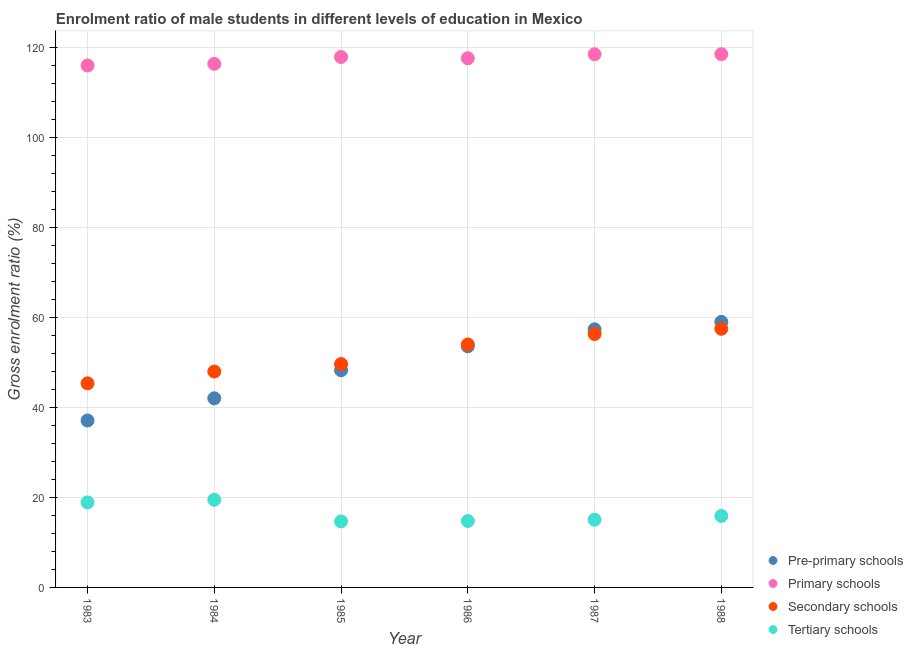What is the gross enrolment ratio(female) in tertiary schools in 1985?
Your response must be concise. 14.66. Across all years, what is the maximum gross enrolment ratio(female) in secondary schools?
Ensure brevity in your answer.  57.43. Across all years, what is the minimum gross enrolment ratio(female) in tertiary schools?
Your answer should be very brief. 14.66. In which year was the gross enrolment ratio(female) in secondary schools maximum?
Provide a short and direct response. 1988. What is the total gross enrolment ratio(female) in tertiary schools in the graph?
Offer a very short reply. 98.69. What is the difference between the gross enrolment ratio(female) in pre-primary schools in 1985 and that in 1988?
Give a very brief answer. -10.76. What is the difference between the gross enrolment ratio(female) in primary schools in 1985 and the gross enrolment ratio(female) in tertiary schools in 1986?
Offer a terse response. 103.05. What is the average gross enrolment ratio(female) in primary schools per year?
Offer a very short reply. 117.4. In the year 1987, what is the difference between the gross enrolment ratio(female) in primary schools and gross enrolment ratio(female) in pre-primary schools?
Offer a very short reply. 61.1. What is the ratio of the gross enrolment ratio(female) in secondary schools in 1987 to that in 1988?
Ensure brevity in your answer.  0.98. Is the difference between the gross enrolment ratio(female) in secondary schools in 1984 and 1988 greater than the difference between the gross enrolment ratio(female) in primary schools in 1984 and 1988?
Offer a very short reply. No. What is the difference between the highest and the second highest gross enrolment ratio(female) in secondary schools?
Give a very brief answer. 1.15. What is the difference between the highest and the lowest gross enrolment ratio(female) in tertiary schools?
Your response must be concise. 4.8. In how many years, is the gross enrolment ratio(female) in pre-primary schools greater than the average gross enrolment ratio(female) in pre-primary schools taken over all years?
Provide a succinct answer. 3. Is it the case that in every year, the sum of the gross enrolment ratio(female) in primary schools and gross enrolment ratio(female) in tertiary schools is greater than the sum of gross enrolment ratio(female) in secondary schools and gross enrolment ratio(female) in pre-primary schools?
Provide a succinct answer. No. Is it the case that in every year, the sum of the gross enrolment ratio(female) in pre-primary schools and gross enrolment ratio(female) in primary schools is greater than the gross enrolment ratio(female) in secondary schools?
Ensure brevity in your answer.  Yes. Does the gross enrolment ratio(female) in secondary schools monotonically increase over the years?
Make the answer very short. Yes. Is the gross enrolment ratio(female) in secondary schools strictly greater than the gross enrolment ratio(female) in tertiary schools over the years?
Your answer should be very brief. Yes. Is the gross enrolment ratio(female) in primary schools strictly less than the gross enrolment ratio(female) in pre-primary schools over the years?
Ensure brevity in your answer.  No. How many years are there in the graph?
Ensure brevity in your answer.  6. What is the difference between two consecutive major ticks on the Y-axis?
Your answer should be very brief. 20. Does the graph contain any zero values?
Your response must be concise. No. How are the legend labels stacked?
Your answer should be compact. Vertical. What is the title of the graph?
Your answer should be compact. Enrolment ratio of male students in different levels of education in Mexico. What is the label or title of the X-axis?
Ensure brevity in your answer.  Year. What is the label or title of the Y-axis?
Keep it short and to the point. Gross enrolment ratio (%). What is the Gross enrolment ratio (%) in Pre-primary schools in 1983?
Make the answer very short. 37.08. What is the Gross enrolment ratio (%) of Primary schools in 1983?
Your response must be concise. 115.92. What is the Gross enrolment ratio (%) of Secondary schools in 1983?
Your response must be concise. 45.33. What is the Gross enrolment ratio (%) of Tertiary schools in 1983?
Your answer should be very brief. 18.89. What is the Gross enrolment ratio (%) of Pre-primary schools in 1984?
Your response must be concise. 42.01. What is the Gross enrolment ratio (%) of Primary schools in 1984?
Provide a short and direct response. 116.28. What is the Gross enrolment ratio (%) of Secondary schools in 1984?
Make the answer very short. 47.94. What is the Gross enrolment ratio (%) of Tertiary schools in 1984?
Your response must be concise. 19.46. What is the Gross enrolment ratio (%) in Pre-primary schools in 1985?
Give a very brief answer. 48.21. What is the Gross enrolment ratio (%) of Primary schools in 1985?
Your answer should be compact. 117.81. What is the Gross enrolment ratio (%) of Secondary schools in 1985?
Your answer should be very brief. 49.62. What is the Gross enrolment ratio (%) in Tertiary schools in 1985?
Make the answer very short. 14.66. What is the Gross enrolment ratio (%) in Pre-primary schools in 1986?
Offer a terse response. 53.54. What is the Gross enrolment ratio (%) in Primary schools in 1986?
Your response must be concise. 117.53. What is the Gross enrolment ratio (%) in Secondary schools in 1986?
Provide a short and direct response. 53.95. What is the Gross enrolment ratio (%) in Tertiary schools in 1986?
Offer a very short reply. 14.75. What is the Gross enrolment ratio (%) in Pre-primary schools in 1987?
Make the answer very short. 57.32. What is the Gross enrolment ratio (%) in Primary schools in 1987?
Keep it short and to the point. 118.42. What is the Gross enrolment ratio (%) in Secondary schools in 1987?
Your answer should be compact. 56.28. What is the Gross enrolment ratio (%) in Tertiary schools in 1987?
Give a very brief answer. 15.04. What is the Gross enrolment ratio (%) in Pre-primary schools in 1988?
Your response must be concise. 58.97. What is the Gross enrolment ratio (%) of Primary schools in 1988?
Your answer should be compact. 118.43. What is the Gross enrolment ratio (%) of Secondary schools in 1988?
Make the answer very short. 57.43. What is the Gross enrolment ratio (%) in Tertiary schools in 1988?
Offer a very short reply. 15.88. Across all years, what is the maximum Gross enrolment ratio (%) in Pre-primary schools?
Your answer should be very brief. 58.97. Across all years, what is the maximum Gross enrolment ratio (%) in Primary schools?
Provide a succinct answer. 118.43. Across all years, what is the maximum Gross enrolment ratio (%) of Secondary schools?
Give a very brief answer. 57.43. Across all years, what is the maximum Gross enrolment ratio (%) of Tertiary schools?
Give a very brief answer. 19.46. Across all years, what is the minimum Gross enrolment ratio (%) in Pre-primary schools?
Provide a short and direct response. 37.08. Across all years, what is the minimum Gross enrolment ratio (%) of Primary schools?
Your answer should be very brief. 115.92. Across all years, what is the minimum Gross enrolment ratio (%) in Secondary schools?
Your response must be concise. 45.33. Across all years, what is the minimum Gross enrolment ratio (%) of Tertiary schools?
Provide a short and direct response. 14.66. What is the total Gross enrolment ratio (%) of Pre-primary schools in the graph?
Offer a terse response. 297.13. What is the total Gross enrolment ratio (%) of Primary schools in the graph?
Ensure brevity in your answer.  704.38. What is the total Gross enrolment ratio (%) of Secondary schools in the graph?
Your answer should be compact. 310.55. What is the total Gross enrolment ratio (%) of Tertiary schools in the graph?
Offer a very short reply. 98.69. What is the difference between the Gross enrolment ratio (%) in Pre-primary schools in 1983 and that in 1984?
Your response must be concise. -4.93. What is the difference between the Gross enrolment ratio (%) of Primary schools in 1983 and that in 1984?
Keep it short and to the point. -0.36. What is the difference between the Gross enrolment ratio (%) of Secondary schools in 1983 and that in 1984?
Offer a terse response. -2.61. What is the difference between the Gross enrolment ratio (%) of Tertiary schools in 1983 and that in 1984?
Your answer should be compact. -0.58. What is the difference between the Gross enrolment ratio (%) of Pre-primary schools in 1983 and that in 1985?
Your answer should be very brief. -11.14. What is the difference between the Gross enrolment ratio (%) of Primary schools in 1983 and that in 1985?
Make the answer very short. -1.89. What is the difference between the Gross enrolment ratio (%) in Secondary schools in 1983 and that in 1985?
Keep it short and to the point. -4.29. What is the difference between the Gross enrolment ratio (%) of Tertiary schools in 1983 and that in 1985?
Offer a terse response. 4.23. What is the difference between the Gross enrolment ratio (%) of Pre-primary schools in 1983 and that in 1986?
Offer a very short reply. -16.46. What is the difference between the Gross enrolment ratio (%) in Primary schools in 1983 and that in 1986?
Offer a very short reply. -1.61. What is the difference between the Gross enrolment ratio (%) of Secondary schools in 1983 and that in 1986?
Provide a short and direct response. -8.62. What is the difference between the Gross enrolment ratio (%) of Tertiary schools in 1983 and that in 1986?
Make the answer very short. 4.13. What is the difference between the Gross enrolment ratio (%) in Pre-primary schools in 1983 and that in 1987?
Make the answer very short. -20.24. What is the difference between the Gross enrolment ratio (%) in Primary schools in 1983 and that in 1987?
Provide a succinct answer. -2.5. What is the difference between the Gross enrolment ratio (%) in Secondary schools in 1983 and that in 1987?
Ensure brevity in your answer.  -10.95. What is the difference between the Gross enrolment ratio (%) in Tertiary schools in 1983 and that in 1987?
Offer a very short reply. 3.85. What is the difference between the Gross enrolment ratio (%) in Pre-primary schools in 1983 and that in 1988?
Give a very brief answer. -21.9. What is the difference between the Gross enrolment ratio (%) of Primary schools in 1983 and that in 1988?
Your response must be concise. -2.51. What is the difference between the Gross enrolment ratio (%) in Secondary schools in 1983 and that in 1988?
Provide a succinct answer. -12.11. What is the difference between the Gross enrolment ratio (%) of Tertiary schools in 1983 and that in 1988?
Your answer should be compact. 3.01. What is the difference between the Gross enrolment ratio (%) of Pre-primary schools in 1984 and that in 1985?
Your answer should be very brief. -6.21. What is the difference between the Gross enrolment ratio (%) of Primary schools in 1984 and that in 1985?
Keep it short and to the point. -1.53. What is the difference between the Gross enrolment ratio (%) in Secondary schools in 1984 and that in 1985?
Offer a terse response. -1.68. What is the difference between the Gross enrolment ratio (%) of Tertiary schools in 1984 and that in 1985?
Give a very brief answer. 4.8. What is the difference between the Gross enrolment ratio (%) of Pre-primary schools in 1984 and that in 1986?
Provide a succinct answer. -11.54. What is the difference between the Gross enrolment ratio (%) in Primary schools in 1984 and that in 1986?
Your answer should be compact. -1.25. What is the difference between the Gross enrolment ratio (%) in Secondary schools in 1984 and that in 1986?
Offer a terse response. -6.01. What is the difference between the Gross enrolment ratio (%) of Tertiary schools in 1984 and that in 1986?
Provide a short and direct response. 4.71. What is the difference between the Gross enrolment ratio (%) in Pre-primary schools in 1984 and that in 1987?
Provide a short and direct response. -15.32. What is the difference between the Gross enrolment ratio (%) of Primary schools in 1984 and that in 1987?
Your answer should be very brief. -2.14. What is the difference between the Gross enrolment ratio (%) in Secondary schools in 1984 and that in 1987?
Your response must be concise. -8.34. What is the difference between the Gross enrolment ratio (%) in Tertiary schools in 1984 and that in 1987?
Your answer should be very brief. 4.42. What is the difference between the Gross enrolment ratio (%) of Pre-primary schools in 1984 and that in 1988?
Ensure brevity in your answer.  -16.97. What is the difference between the Gross enrolment ratio (%) in Primary schools in 1984 and that in 1988?
Provide a short and direct response. -2.15. What is the difference between the Gross enrolment ratio (%) of Secondary schools in 1984 and that in 1988?
Offer a terse response. -9.49. What is the difference between the Gross enrolment ratio (%) of Tertiary schools in 1984 and that in 1988?
Keep it short and to the point. 3.59. What is the difference between the Gross enrolment ratio (%) in Pre-primary schools in 1985 and that in 1986?
Offer a very short reply. -5.33. What is the difference between the Gross enrolment ratio (%) in Primary schools in 1985 and that in 1986?
Provide a short and direct response. 0.28. What is the difference between the Gross enrolment ratio (%) of Secondary schools in 1985 and that in 1986?
Give a very brief answer. -4.33. What is the difference between the Gross enrolment ratio (%) of Tertiary schools in 1985 and that in 1986?
Provide a short and direct response. -0.09. What is the difference between the Gross enrolment ratio (%) in Pre-primary schools in 1985 and that in 1987?
Make the answer very short. -9.11. What is the difference between the Gross enrolment ratio (%) in Primary schools in 1985 and that in 1987?
Provide a short and direct response. -0.61. What is the difference between the Gross enrolment ratio (%) in Secondary schools in 1985 and that in 1987?
Offer a terse response. -6.66. What is the difference between the Gross enrolment ratio (%) in Tertiary schools in 1985 and that in 1987?
Your response must be concise. -0.38. What is the difference between the Gross enrolment ratio (%) in Pre-primary schools in 1985 and that in 1988?
Offer a very short reply. -10.76. What is the difference between the Gross enrolment ratio (%) of Primary schools in 1985 and that in 1988?
Ensure brevity in your answer.  -0.62. What is the difference between the Gross enrolment ratio (%) in Secondary schools in 1985 and that in 1988?
Your response must be concise. -7.82. What is the difference between the Gross enrolment ratio (%) of Tertiary schools in 1985 and that in 1988?
Keep it short and to the point. -1.21. What is the difference between the Gross enrolment ratio (%) in Pre-primary schools in 1986 and that in 1987?
Ensure brevity in your answer.  -3.78. What is the difference between the Gross enrolment ratio (%) of Primary schools in 1986 and that in 1987?
Ensure brevity in your answer.  -0.9. What is the difference between the Gross enrolment ratio (%) of Secondary schools in 1986 and that in 1987?
Keep it short and to the point. -2.33. What is the difference between the Gross enrolment ratio (%) of Tertiary schools in 1986 and that in 1987?
Your answer should be compact. -0.29. What is the difference between the Gross enrolment ratio (%) of Pre-primary schools in 1986 and that in 1988?
Make the answer very short. -5.43. What is the difference between the Gross enrolment ratio (%) of Primary schools in 1986 and that in 1988?
Make the answer very short. -0.9. What is the difference between the Gross enrolment ratio (%) in Secondary schools in 1986 and that in 1988?
Give a very brief answer. -3.49. What is the difference between the Gross enrolment ratio (%) in Tertiary schools in 1986 and that in 1988?
Provide a short and direct response. -1.12. What is the difference between the Gross enrolment ratio (%) of Pre-primary schools in 1987 and that in 1988?
Your answer should be compact. -1.65. What is the difference between the Gross enrolment ratio (%) of Primary schools in 1987 and that in 1988?
Provide a short and direct response. -0.01. What is the difference between the Gross enrolment ratio (%) of Secondary schools in 1987 and that in 1988?
Provide a short and direct response. -1.15. What is the difference between the Gross enrolment ratio (%) in Tertiary schools in 1987 and that in 1988?
Your answer should be compact. -0.83. What is the difference between the Gross enrolment ratio (%) in Pre-primary schools in 1983 and the Gross enrolment ratio (%) in Primary schools in 1984?
Provide a succinct answer. -79.2. What is the difference between the Gross enrolment ratio (%) of Pre-primary schools in 1983 and the Gross enrolment ratio (%) of Secondary schools in 1984?
Provide a succinct answer. -10.86. What is the difference between the Gross enrolment ratio (%) of Pre-primary schools in 1983 and the Gross enrolment ratio (%) of Tertiary schools in 1984?
Provide a succinct answer. 17.61. What is the difference between the Gross enrolment ratio (%) in Primary schools in 1983 and the Gross enrolment ratio (%) in Secondary schools in 1984?
Give a very brief answer. 67.98. What is the difference between the Gross enrolment ratio (%) of Primary schools in 1983 and the Gross enrolment ratio (%) of Tertiary schools in 1984?
Provide a succinct answer. 96.45. What is the difference between the Gross enrolment ratio (%) of Secondary schools in 1983 and the Gross enrolment ratio (%) of Tertiary schools in 1984?
Make the answer very short. 25.86. What is the difference between the Gross enrolment ratio (%) of Pre-primary schools in 1983 and the Gross enrolment ratio (%) of Primary schools in 1985?
Offer a very short reply. -80.73. What is the difference between the Gross enrolment ratio (%) in Pre-primary schools in 1983 and the Gross enrolment ratio (%) in Secondary schools in 1985?
Your response must be concise. -12.54. What is the difference between the Gross enrolment ratio (%) in Pre-primary schools in 1983 and the Gross enrolment ratio (%) in Tertiary schools in 1985?
Your answer should be compact. 22.42. What is the difference between the Gross enrolment ratio (%) of Primary schools in 1983 and the Gross enrolment ratio (%) of Secondary schools in 1985?
Your response must be concise. 66.3. What is the difference between the Gross enrolment ratio (%) in Primary schools in 1983 and the Gross enrolment ratio (%) in Tertiary schools in 1985?
Give a very brief answer. 101.25. What is the difference between the Gross enrolment ratio (%) in Secondary schools in 1983 and the Gross enrolment ratio (%) in Tertiary schools in 1985?
Your response must be concise. 30.66. What is the difference between the Gross enrolment ratio (%) in Pre-primary schools in 1983 and the Gross enrolment ratio (%) in Primary schools in 1986?
Offer a terse response. -80.45. What is the difference between the Gross enrolment ratio (%) in Pre-primary schools in 1983 and the Gross enrolment ratio (%) in Secondary schools in 1986?
Offer a very short reply. -16.87. What is the difference between the Gross enrolment ratio (%) in Pre-primary schools in 1983 and the Gross enrolment ratio (%) in Tertiary schools in 1986?
Make the answer very short. 22.32. What is the difference between the Gross enrolment ratio (%) in Primary schools in 1983 and the Gross enrolment ratio (%) in Secondary schools in 1986?
Provide a short and direct response. 61.97. What is the difference between the Gross enrolment ratio (%) of Primary schools in 1983 and the Gross enrolment ratio (%) of Tertiary schools in 1986?
Keep it short and to the point. 101.16. What is the difference between the Gross enrolment ratio (%) in Secondary schools in 1983 and the Gross enrolment ratio (%) in Tertiary schools in 1986?
Make the answer very short. 30.57. What is the difference between the Gross enrolment ratio (%) in Pre-primary schools in 1983 and the Gross enrolment ratio (%) in Primary schools in 1987?
Offer a terse response. -81.34. What is the difference between the Gross enrolment ratio (%) of Pre-primary schools in 1983 and the Gross enrolment ratio (%) of Secondary schools in 1987?
Your answer should be compact. -19.2. What is the difference between the Gross enrolment ratio (%) of Pre-primary schools in 1983 and the Gross enrolment ratio (%) of Tertiary schools in 1987?
Offer a very short reply. 22.04. What is the difference between the Gross enrolment ratio (%) of Primary schools in 1983 and the Gross enrolment ratio (%) of Secondary schools in 1987?
Offer a terse response. 59.64. What is the difference between the Gross enrolment ratio (%) in Primary schools in 1983 and the Gross enrolment ratio (%) in Tertiary schools in 1987?
Ensure brevity in your answer.  100.87. What is the difference between the Gross enrolment ratio (%) of Secondary schools in 1983 and the Gross enrolment ratio (%) of Tertiary schools in 1987?
Make the answer very short. 30.28. What is the difference between the Gross enrolment ratio (%) in Pre-primary schools in 1983 and the Gross enrolment ratio (%) in Primary schools in 1988?
Provide a succinct answer. -81.35. What is the difference between the Gross enrolment ratio (%) of Pre-primary schools in 1983 and the Gross enrolment ratio (%) of Secondary schools in 1988?
Keep it short and to the point. -20.36. What is the difference between the Gross enrolment ratio (%) in Pre-primary schools in 1983 and the Gross enrolment ratio (%) in Tertiary schools in 1988?
Provide a succinct answer. 21.2. What is the difference between the Gross enrolment ratio (%) of Primary schools in 1983 and the Gross enrolment ratio (%) of Secondary schools in 1988?
Provide a short and direct response. 58.48. What is the difference between the Gross enrolment ratio (%) of Primary schools in 1983 and the Gross enrolment ratio (%) of Tertiary schools in 1988?
Offer a terse response. 100.04. What is the difference between the Gross enrolment ratio (%) of Secondary schools in 1983 and the Gross enrolment ratio (%) of Tertiary schools in 1988?
Ensure brevity in your answer.  29.45. What is the difference between the Gross enrolment ratio (%) in Pre-primary schools in 1984 and the Gross enrolment ratio (%) in Primary schools in 1985?
Your answer should be compact. -75.8. What is the difference between the Gross enrolment ratio (%) in Pre-primary schools in 1984 and the Gross enrolment ratio (%) in Secondary schools in 1985?
Offer a very short reply. -7.61. What is the difference between the Gross enrolment ratio (%) of Pre-primary schools in 1984 and the Gross enrolment ratio (%) of Tertiary schools in 1985?
Keep it short and to the point. 27.34. What is the difference between the Gross enrolment ratio (%) in Primary schools in 1984 and the Gross enrolment ratio (%) in Secondary schools in 1985?
Provide a succinct answer. 66.66. What is the difference between the Gross enrolment ratio (%) in Primary schools in 1984 and the Gross enrolment ratio (%) in Tertiary schools in 1985?
Your answer should be compact. 101.61. What is the difference between the Gross enrolment ratio (%) of Secondary schools in 1984 and the Gross enrolment ratio (%) of Tertiary schools in 1985?
Your answer should be very brief. 33.28. What is the difference between the Gross enrolment ratio (%) of Pre-primary schools in 1984 and the Gross enrolment ratio (%) of Primary schools in 1986?
Provide a short and direct response. -75.52. What is the difference between the Gross enrolment ratio (%) of Pre-primary schools in 1984 and the Gross enrolment ratio (%) of Secondary schools in 1986?
Give a very brief answer. -11.94. What is the difference between the Gross enrolment ratio (%) of Pre-primary schools in 1984 and the Gross enrolment ratio (%) of Tertiary schools in 1986?
Your answer should be compact. 27.25. What is the difference between the Gross enrolment ratio (%) of Primary schools in 1984 and the Gross enrolment ratio (%) of Secondary schools in 1986?
Provide a succinct answer. 62.33. What is the difference between the Gross enrolment ratio (%) in Primary schools in 1984 and the Gross enrolment ratio (%) in Tertiary schools in 1986?
Your answer should be very brief. 101.52. What is the difference between the Gross enrolment ratio (%) in Secondary schools in 1984 and the Gross enrolment ratio (%) in Tertiary schools in 1986?
Ensure brevity in your answer.  33.19. What is the difference between the Gross enrolment ratio (%) in Pre-primary schools in 1984 and the Gross enrolment ratio (%) in Primary schools in 1987?
Provide a succinct answer. -76.42. What is the difference between the Gross enrolment ratio (%) of Pre-primary schools in 1984 and the Gross enrolment ratio (%) of Secondary schools in 1987?
Make the answer very short. -14.27. What is the difference between the Gross enrolment ratio (%) of Pre-primary schools in 1984 and the Gross enrolment ratio (%) of Tertiary schools in 1987?
Your response must be concise. 26.96. What is the difference between the Gross enrolment ratio (%) in Primary schools in 1984 and the Gross enrolment ratio (%) in Secondary schools in 1987?
Offer a terse response. 60. What is the difference between the Gross enrolment ratio (%) in Primary schools in 1984 and the Gross enrolment ratio (%) in Tertiary schools in 1987?
Your answer should be compact. 101.23. What is the difference between the Gross enrolment ratio (%) in Secondary schools in 1984 and the Gross enrolment ratio (%) in Tertiary schools in 1987?
Ensure brevity in your answer.  32.9. What is the difference between the Gross enrolment ratio (%) in Pre-primary schools in 1984 and the Gross enrolment ratio (%) in Primary schools in 1988?
Keep it short and to the point. -76.42. What is the difference between the Gross enrolment ratio (%) of Pre-primary schools in 1984 and the Gross enrolment ratio (%) of Secondary schools in 1988?
Offer a terse response. -15.43. What is the difference between the Gross enrolment ratio (%) of Pre-primary schools in 1984 and the Gross enrolment ratio (%) of Tertiary schools in 1988?
Provide a succinct answer. 26.13. What is the difference between the Gross enrolment ratio (%) of Primary schools in 1984 and the Gross enrolment ratio (%) of Secondary schools in 1988?
Your answer should be compact. 58.84. What is the difference between the Gross enrolment ratio (%) in Primary schools in 1984 and the Gross enrolment ratio (%) in Tertiary schools in 1988?
Give a very brief answer. 100.4. What is the difference between the Gross enrolment ratio (%) in Secondary schools in 1984 and the Gross enrolment ratio (%) in Tertiary schools in 1988?
Give a very brief answer. 32.07. What is the difference between the Gross enrolment ratio (%) in Pre-primary schools in 1985 and the Gross enrolment ratio (%) in Primary schools in 1986?
Make the answer very short. -69.31. What is the difference between the Gross enrolment ratio (%) in Pre-primary schools in 1985 and the Gross enrolment ratio (%) in Secondary schools in 1986?
Provide a succinct answer. -5.74. What is the difference between the Gross enrolment ratio (%) of Pre-primary schools in 1985 and the Gross enrolment ratio (%) of Tertiary schools in 1986?
Give a very brief answer. 33.46. What is the difference between the Gross enrolment ratio (%) of Primary schools in 1985 and the Gross enrolment ratio (%) of Secondary schools in 1986?
Give a very brief answer. 63.86. What is the difference between the Gross enrolment ratio (%) of Primary schools in 1985 and the Gross enrolment ratio (%) of Tertiary schools in 1986?
Offer a very short reply. 103.05. What is the difference between the Gross enrolment ratio (%) of Secondary schools in 1985 and the Gross enrolment ratio (%) of Tertiary schools in 1986?
Provide a short and direct response. 34.86. What is the difference between the Gross enrolment ratio (%) of Pre-primary schools in 1985 and the Gross enrolment ratio (%) of Primary schools in 1987?
Your response must be concise. -70.21. What is the difference between the Gross enrolment ratio (%) in Pre-primary schools in 1985 and the Gross enrolment ratio (%) in Secondary schools in 1987?
Your answer should be very brief. -8.07. What is the difference between the Gross enrolment ratio (%) of Pre-primary schools in 1985 and the Gross enrolment ratio (%) of Tertiary schools in 1987?
Give a very brief answer. 33.17. What is the difference between the Gross enrolment ratio (%) in Primary schools in 1985 and the Gross enrolment ratio (%) in Secondary schools in 1987?
Provide a short and direct response. 61.53. What is the difference between the Gross enrolment ratio (%) in Primary schools in 1985 and the Gross enrolment ratio (%) in Tertiary schools in 1987?
Offer a terse response. 102.77. What is the difference between the Gross enrolment ratio (%) in Secondary schools in 1985 and the Gross enrolment ratio (%) in Tertiary schools in 1987?
Offer a terse response. 34.57. What is the difference between the Gross enrolment ratio (%) of Pre-primary schools in 1985 and the Gross enrolment ratio (%) of Primary schools in 1988?
Give a very brief answer. -70.21. What is the difference between the Gross enrolment ratio (%) of Pre-primary schools in 1985 and the Gross enrolment ratio (%) of Secondary schools in 1988?
Your answer should be very brief. -9.22. What is the difference between the Gross enrolment ratio (%) in Pre-primary schools in 1985 and the Gross enrolment ratio (%) in Tertiary schools in 1988?
Offer a terse response. 32.34. What is the difference between the Gross enrolment ratio (%) of Primary schools in 1985 and the Gross enrolment ratio (%) of Secondary schools in 1988?
Give a very brief answer. 60.37. What is the difference between the Gross enrolment ratio (%) of Primary schools in 1985 and the Gross enrolment ratio (%) of Tertiary schools in 1988?
Your answer should be compact. 101.93. What is the difference between the Gross enrolment ratio (%) in Secondary schools in 1985 and the Gross enrolment ratio (%) in Tertiary schools in 1988?
Your response must be concise. 33.74. What is the difference between the Gross enrolment ratio (%) in Pre-primary schools in 1986 and the Gross enrolment ratio (%) in Primary schools in 1987?
Offer a terse response. -64.88. What is the difference between the Gross enrolment ratio (%) of Pre-primary schools in 1986 and the Gross enrolment ratio (%) of Secondary schools in 1987?
Ensure brevity in your answer.  -2.74. What is the difference between the Gross enrolment ratio (%) in Pre-primary schools in 1986 and the Gross enrolment ratio (%) in Tertiary schools in 1987?
Provide a succinct answer. 38.5. What is the difference between the Gross enrolment ratio (%) of Primary schools in 1986 and the Gross enrolment ratio (%) of Secondary schools in 1987?
Make the answer very short. 61.25. What is the difference between the Gross enrolment ratio (%) in Primary schools in 1986 and the Gross enrolment ratio (%) in Tertiary schools in 1987?
Make the answer very short. 102.48. What is the difference between the Gross enrolment ratio (%) in Secondary schools in 1986 and the Gross enrolment ratio (%) in Tertiary schools in 1987?
Keep it short and to the point. 38.91. What is the difference between the Gross enrolment ratio (%) in Pre-primary schools in 1986 and the Gross enrolment ratio (%) in Primary schools in 1988?
Give a very brief answer. -64.89. What is the difference between the Gross enrolment ratio (%) of Pre-primary schools in 1986 and the Gross enrolment ratio (%) of Secondary schools in 1988?
Offer a very short reply. -3.89. What is the difference between the Gross enrolment ratio (%) in Pre-primary schools in 1986 and the Gross enrolment ratio (%) in Tertiary schools in 1988?
Keep it short and to the point. 37.67. What is the difference between the Gross enrolment ratio (%) in Primary schools in 1986 and the Gross enrolment ratio (%) in Secondary schools in 1988?
Keep it short and to the point. 60.09. What is the difference between the Gross enrolment ratio (%) of Primary schools in 1986 and the Gross enrolment ratio (%) of Tertiary schools in 1988?
Keep it short and to the point. 101.65. What is the difference between the Gross enrolment ratio (%) of Secondary schools in 1986 and the Gross enrolment ratio (%) of Tertiary schools in 1988?
Offer a very short reply. 38.07. What is the difference between the Gross enrolment ratio (%) of Pre-primary schools in 1987 and the Gross enrolment ratio (%) of Primary schools in 1988?
Your answer should be very brief. -61.11. What is the difference between the Gross enrolment ratio (%) in Pre-primary schools in 1987 and the Gross enrolment ratio (%) in Secondary schools in 1988?
Make the answer very short. -0.11. What is the difference between the Gross enrolment ratio (%) of Pre-primary schools in 1987 and the Gross enrolment ratio (%) of Tertiary schools in 1988?
Offer a very short reply. 41.45. What is the difference between the Gross enrolment ratio (%) of Primary schools in 1987 and the Gross enrolment ratio (%) of Secondary schools in 1988?
Ensure brevity in your answer.  60.99. What is the difference between the Gross enrolment ratio (%) in Primary schools in 1987 and the Gross enrolment ratio (%) in Tertiary schools in 1988?
Make the answer very short. 102.55. What is the difference between the Gross enrolment ratio (%) in Secondary schools in 1987 and the Gross enrolment ratio (%) in Tertiary schools in 1988?
Provide a short and direct response. 40.41. What is the average Gross enrolment ratio (%) in Pre-primary schools per year?
Your answer should be very brief. 49.52. What is the average Gross enrolment ratio (%) of Primary schools per year?
Give a very brief answer. 117.4. What is the average Gross enrolment ratio (%) in Secondary schools per year?
Your answer should be very brief. 51.76. What is the average Gross enrolment ratio (%) of Tertiary schools per year?
Your response must be concise. 16.45. In the year 1983, what is the difference between the Gross enrolment ratio (%) of Pre-primary schools and Gross enrolment ratio (%) of Primary schools?
Offer a terse response. -78.84. In the year 1983, what is the difference between the Gross enrolment ratio (%) of Pre-primary schools and Gross enrolment ratio (%) of Secondary schools?
Your response must be concise. -8.25. In the year 1983, what is the difference between the Gross enrolment ratio (%) of Pre-primary schools and Gross enrolment ratio (%) of Tertiary schools?
Provide a succinct answer. 18.19. In the year 1983, what is the difference between the Gross enrolment ratio (%) in Primary schools and Gross enrolment ratio (%) in Secondary schools?
Your answer should be very brief. 70.59. In the year 1983, what is the difference between the Gross enrolment ratio (%) of Primary schools and Gross enrolment ratio (%) of Tertiary schools?
Offer a very short reply. 97.03. In the year 1983, what is the difference between the Gross enrolment ratio (%) in Secondary schools and Gross enrolment ratio (%) in Tertiary schools?
Offer a very short reply. 26.44. In the year 1984, what is the difference between the Gross enrolment ratio (%) in Pre-primary schools and Gross enrolment ratio (%) in Primary schools?
Ensure brevity in your answer.  -74.27. In the year 1984, what is the difference between the Gross enrolment ratio (%) of Pre-primary schools and Gross enrolment ratio (%) of Secondary schools?
Provide a short and direct response. -5.94. In the year 1984, what is the difference between the Gross enrolment ratio (%) of Pre-primary schools and Gross enrolment ratio (%) of Tertiary schools?
Offer a terse response. 22.54. In the year 1984, what is the difference between the Gross enrolment ratio (%) in Primary schools and Gross enrolment ratio (%) in Secondary schools?
Your response must be concise. 68.34. In the year 1984, what is the difference between the Gross enrolment ratio (%) of Primary schools and Gross enrolment ratio (%) of Tertiary schools?
Offer a very short reply. 96.81. In the year 1984, what is the difference between the Gross enrolment ratio (%) of Secondary schools and Gross enrolment ratio (%) of Tertiary schools?
Your answer should be compact. 28.48. In the year 1985, what is the difference between the Gross enrolment ratio (%) of Pre-primary schools and Gross enrolment ratio (%) of Primary schools?
Provide a short and direct response. -69.59. In the year 1985, what is the difference between the Gross enrolment ratio (%) of Pre-primary schools and Gross enrolment ratio (%) of Secondary schools?
Your response must be concise. -1.4. In the year 1985, what is the difference between the Gross enrolment ratio (%) in Pre-primary schools and Gross enrolment ratio (%) in Tertiary schools?
Your answer should be compact. 33.55. In the year 1985, what is the difference between the Gross enrolment ratio (%) of Primary schools and Gross enrolment ratio (%) of Secondary schools?
Provide a succinct answer. 68.19. In the year 1985, what is the difference between the Gross enrolment ratio (%) in Primary schools and Gross enrolment ratio (%) in Tertiary schools?
Your answer should be compact. 103.15. In the year 1985, what is the difference between the Gross enrolment ratio (%) of Secondary schools and Gross enrolment ratio (%) of Tertiary schools?
Make the answer very short. 34.95. In the year 1986, what is the difference between the Gross enrolment ratio (%) in Pre-primary schools and Gross enrolment ratio (%) in Primary schools?
Keep it short and to the point. -63.99. In the year 1986, what is the difference between the Gross enrolment ratio (%) in Pre-primary schools and Gross enrolment ratio (%) in Secondary schools?
Give a very brief answer. -0.41. In the year 1986, what is the difference between the Gross enrolment ratio (%) of Pre-primary schools and Gross enrolment ratio (%) of Tertiary schools?
Offer a very short reply. 38.79. In the year 1986, what is the difference between the Gross enrolment ratio (%) in Primary schools and Gross enrolment ratio (%) in Secondary schools?
Your response must be concise. 63.58. In the year 1986, what is the difference between the Gross enrolment ratio (%) of Primary schools and Gross enrolment ratio (%) of Tertiary schools?
Offer a very short reply. 102.77. In the year 1986, what is the difference between the Gross enrolment ratio (%) in Secondary schools and Gross enrolment ratio (%) in Tertiary schools?
Your response must be concise. 39.2. In the year 1987, what is the difference between the Gross enrolment ratio (%) of Pre-primary schools and Gross enrolment ratio (%) of Primary schools?
Offer a terse response. -61.1. In the year 1987, what is the difference between the Gross enrolment ratio (%) in Pre-primary schools and Gross enrolment ratio (%) in Secondary schools?
Ensure brevity in your answer.  1.04. In the year 1987, what is the difference between the Gross enrolment ratio (%) of Pre-primary schools and Gross enrolment ratio (%) of Tertiary schools?
Provide a short and direct response. 42.28. In the year 1987, what is the difference between the Gross enrolment ratio (%) in Primary schools and Gross enrolment ratio (%) in Secondary schools?
Your answer should be very brief. 62.14. In the year 1987, what is the difference between the Gross enrolment ratio (%) of Primary schools and Gross enrolment ratio (%) of Tertiary schools?
Your answer should be compact. 103.38. In the year 1987, what is the difference between the Gross enrolment ratio (%) of Secondary schools and Gross enrolment ratio (%) of Tertiary schools?
Your answer should be compact. 41.24. In the year 1988, what is the difference between the Gross enrolment ratio (%) in Pre-primary schools and Gross enrolment ratio (%) in Primary schools?
Provide a short and direct response. -59.45. In the year 1988, what is the difference between the Gross enrolment ratio (%) of Pre-primary schools and Gross enrolment ratio (%) of Secondary schools?
Give a very brief answer. 1.54. In the year 1988, what is the difference between the Gross enrolment ratio (%) in Pre-primary schools and Gross enrolment ratio (%) in Tertiary schools?
Offer a terse response. 43.1. In the year 1988, what is the difference between the Gross enrolment ratio (%) in Primary schools and Gross enrolment ratio (%) in Secondary schools?
Keep it short and to the point. 60.99. In the year 1988, what is the difference between the Gross enrolment ratio (%) of Primary schools and Gross enrolment ratio (%) of Tertiary schools?
Make the answer very short. 102.55. In the year 1988, what is the difference between the Gross enrolment ratio (%) in Secondary schools and Gross enrolment ratio (%) in Tertiary schools?
Your response must be concise. 41.56. What is the ratio of the Gross enrolment ratio (%) in Pre-primary schools in 1983 to that in 1984?
Provide a succinct answer. 0.88. What is the ratio of the Gross enrolment ratio (%) of Primary schools in 1983 to that in 1984?
Offer a very short reply. 1. What is the ratio of the Gross enrolment ratio (%) of Secondary schools in 1983 to that in 1984?
Ensure brevity in your answer.  0.95. What is the ratio of the Gross enrolment ratio (%) of Tertiary schools in 1983 to that in 1984?
Offer a very short reply. 0.97. What is the ratio of the Gross enrolment ratio (%) in Pre-primary schools in 1983 to that in 1985?
Provide a succinct answer. 0.77. What is the ratio of the Gross enrolment ratio (%) in Primary schools in 1983 to that in 1985?
Your response must be concise. 0.98. What is the ratio of the Gross enrolment ratio (%) in Secondary schools in 1983 to that in 1985?
Your response must be concise. 0.91. What is the ratio of the Gross enrolment ratio (%) in Tertiary schools in 1983 to that in 1985?
Offer a terse response. 1.29. What is the ratio of the Gross enrolment ratio (%) of Pre-primary schools in 1983 to that in 1986?
Your answer should be compact. 0.69. What is the ratio of the Gross enrolment ratio (%) of Primary schools in 1983 to that in 1986?
Your answer should be very brief. 0.99. What is the ratio of the Gross enrolment ratio (%) of Secondary schools in 1983 to that in 1986?
Offer a terse response. 0.84. What is the ratio of the Gross enrolment ratio (%) of Tertiary schools in 1983 to that in 1986?
Make the answer very short. 1.28. What is the ratio of the Gross enrolment ratio (%) of Pre-primary schools in 1983 to that in 1987?
Provide a succinct answer. 0.65. What is the ratio of the Gross enrolment ratio (%) in Primary schools in 1983 to that in 1987?
Offer a very short reply. 0.98. What is the ratio of the Gross enrolment ratio (%) in Secondary schools in 1983 to that in 1987?
Keep it short and to the point. 0.81. What is the ratio of the Gross enrolment ratio (%) of Tertiary schools in 1983 to that in 1987?
Your answer should be very brief. 1.26. What is the ratio of the Gross enrolment ratio (%) in Pre-primary schools in 1983 to that in 1988?
Offer a very short reply. 0.63. What is the ratio of the Gross enrolment ratio (%) in Primary schools in 1983 to that in 1988?
Provide a short and direct response. 0.98. What is the ratio of the Gross enrolment ratio (%) of Secondary schools in 1983 to that in 1988?
Provide a succinct answer. 0.79. What is the ratio of the Gross enrolment ratio (%) of Tertiary schools in 1983 to that in 1988?
Make the answer very short. 1.19. What is the ratio of the Gross enrolment ratio (%) of Pre-primary schools in 1984 to that in 1985?
Provide a short and direct response. 0.87. What is the ratio of the Gross enrolment ratio (%) of Primary schools in 1984 to that in 1985?
Offer a very short reply. 0.99. What is the ratio of the Gross enrolment ratio (%) of Secondary schools in 1984 to that in 1985?
Keep it short and to the point. 0.97. What is the ratio of the Gross enrolment ratio (%) in Tertiary schools in 1984 to that in 1985?
Provide a succinct answer. 1.33. What is the ratio of the Gross enrolment ratio (%) in Pre-primary schools in 1984 to that in 1986?
Your answer should be compact. 0.78. What is the ratio of the Gross enrolment ratio (%) of Secondary schools in 1984 to that in 1986?
Provide a succinct answer. 0.89. What is the ratio of the Gross enrolment ratio (%) of Tertiary schools in 1984 to that in 1986?
Provide a short and direct response. 1.32. What is the ratio of the Gross enrolment ratio (%) in Pre-primary schools in 1984 to that in 1987?
Offer a terse response. 0.73. What is the ratio of the Gross enrolment ratio (%) in Primary schools in 1984 to that in 1987?
Your answer should be very brief. 0.98. What is the ratio of the Gross enrolment ratio (%) of Secondary schools in 1984 to that in 1987?
Provide a short and direct response. 0.85. What is the ratio of the Gross enrolment ratio (%) of Tertiary schools in 1984 to that in 1987?
Give a very brief answer. 1.29. What is the ratio of the Gross enrolment ratio (%) in Pre-primary schools in 1984 to that in 1988?
Provide a short and direct response. 0.71. What is the ratio of the Gross enrolment ratio (%) of Primary schools in 1984 to that in 1988?
Ensure brevity in your answer.  0.98. What is the ratio of the Gross enrolment ratio (%) of Secondary schools in 1984 to that in 1988?
Provide a short and direct response. 0.83. What is the ratio of the Gross enrolment ratio (%) of Tertiary schools in 1984 to that in 1988?
Offer a very short reply. 1.23. What is the ratio of the Gross enrolment ratio (%) of Pre-primary schools in 1985 to that in 1986?
Offer a very short reply. 0.9. What is the ratio of the Gross enrolment ratio (%) in Secondary schools in 1985 to that in 1986?
Offer a terse response. 0.92. What is the ratio of the Gross enrolment ratio (%) of Tertiary schools in 1985 to that in 1986?
Offer a terse response. 0.99. What is the ratio of the Gross enrolment ratio (%) of Pre-primary schools in 1985 to that in 1987?
Make the answer very short. 0.84. What is the ratio of the Gross enrolment ratio (%) of Primary schools in 1985 to that in 1987?
Offer a very short reply. 0.99. What is the ratio of the Gross enrolment ratio (%) of Secondary schools in 1985 to that in 1987?
Give a very brief answer. 0.88. What is the ratio of the Gross enrolment ratio (%) in Tertiary schools in 1985 to that in 1987?
Keep it short and to the point. 0.97. What is the ratio of the Gross enrolment ratio (%) of Pre-primary schools in 1985 to that in 1988?
Offer a very short reply. 0.82. What is the ratio of the Gross enrolment ratio (%) of Secondary schools in 1985 to that in 1988?
Ensure brevity in your answer.  0.86. What is the ratio of the Gross enrolment ratio (%) of Tertiary schools in 1985 to that in 1988?
Make the answer very short. 0.92. What is the ratio of the Gross enrolment ratio (%) in Pre-primary schools in 1986 to that in 1987?
Offer a very short reply. 0.93. What is the ratio of the Gross enrolment ratio (%) in Primary schools in 1986 to that in 1987?
Provide a succinct answer. 0.99. What is the ratio of the Gross enrolment ratio (%) of Secondary schools in 1986 to that in 1987?
Give a very brief answer. 0.96. What is the ratio of the Gross enrolment ratio (%) in Tertiary schools in 1986 to that in 1987?
Offer a very short reply. 0.98. What is the ratio of the Gross enrolment ratio (%) in Pre-primary schools in 1986 to that in 1988?
Provide a short and direct response. 0.91. What is the ratio of the Gross enrolment ratio (%) in Primary schools in 1986 to that in 1988?
Your answer should be compact. 0.99. What is the ratio of the Gross enrolment ratio (%) of Secondary schools in 1986 to that in 1988?
Give a very brief answer. 0.94. What is the ratio of the Gross enrolment ratio (%) of Tertiary schools in 1986 to that in 1988?
Your response must be concise. 0.93. What is the ratio of the Gross enrolment ratio (%) of Pre-primary schools in 1987 to that in 1988?
Provide a short and direct response. 0.97. What is the ratio of the Gross enrolment ratio (%) in Primary schools in 1987 to that in 1988?
Offer a terse response. 1. What is the ratio of the Gross enrolment ratio (%) of Secondary schools in 1987 to that in 1988?
Provide a succinct answer. 0.98. What is the ratio of the Gross enrolment ratio (%) of Tertiary schools in 1987 to that in 1988?
Give a very brief answer. 0.95. What is the difference between the highest and the second highest Gross enrolment ratio (%) in Pre-primary schools?
Give a very brief answer. 1.65. What is the difference between the highest and the second highest Gross enrolment ratio (%) in Primary schools?
Provide a short and direct response. 0.01. What is the difference between the highest and the second highest Gross enrolment ratio (%) in Secondary schools?
Your answer should be very brief. 1.15. What is the difference between the highest and the second highest Gross enrolment ratio (%) in Tertiary schools?
Provide a succinct answer. 0.58. What is the difference between the highest and the lowest Gross enrolment ratio (%) of Pre-primary schools?
Ensure brevity in your answer.  21.9. What is the difference between the highest and the lowest Gross enrolment ratio (%) in Primary schools?
Ensure brevity in your answer.  2.51. What is the difference between the highest and the lowest Gross enrolment ratio (%) of Secondary schools?
Ensure brevity in your answer.  12.11. What is the difference between the highest and the lowest Gross enrolment ratio (%) of Tertiary schools?
Keep it short and to the point. 4.8. 